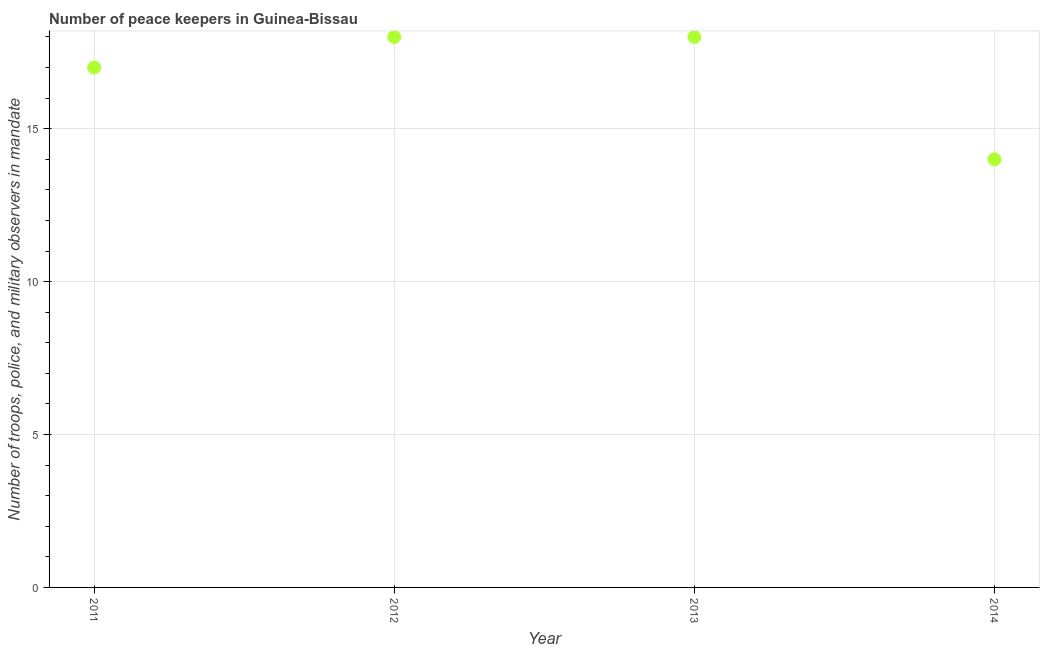What is the number of peace keepers in 2013?
Offer a terse response. 18. Across all years, what is the maximum number of peace keepers?
Ensure brevity in your answer.  18. Across all years, what is the minimum number of peace keepers?
Provide a succinct answer. 14. What is the sum of the number of peace keepers?
Give a very brief answer. 67. What is the difference between the number of peace keepers in 2012 and 2014?
Make the answer very short. 4. What is the average number of peace keepers per year?
Provide a short and direct response. 16.75. What is the ratio of the number of peace keepers in 2011 to that in 2014?
Offer a terse response. 1.21. Is the number of peace keepers in 2011 less than that in 2012?
Your response must be concise. Yes. What is the difference between the highest and the second highest number of peace keepers?
Your response must be concise. 0. Is the sum of the number of peace keepers in 2012 and 2013 greater than the maximum number of peace keepers across all years?
Make the answer very short. Yes. What is the difference between the highest and the lowest number of peace keepers?
Offer a very short reply. 4. In how many years, is the number of peace keepers greater than the average number of peace keepers taken over all years?
Offer a very short reply. 3. How many dotlines are there?
Offer a terse response. 1. Are the values on the major ticks of Y-axis written in scientific E-notation?
Give a very brief answer. No. Does the graph contain any zero values?
Provide a short and direct response. No. What is the title of the graph?
Your answer should be very brief. Number of peace keepers in Guinea-Bissau. What is the label or title of the Y-axis?
Your response must be concise. Number of troops, police, and military observers in mandate. What is the Number of troops, police, and military observers in mandate in 2012?
Ensure brevity in your answer.  18. What is the Number of troops, police, and military observers in mandate in 2014?
Ensure brevity in your answer.  14. What is the difference between the Number of troops, police, and military observers in mandate in 2011 and 2013?
Make the answer very short. -1. What is the difference between the Number of troops, police, and military observers in mandate in 2011 and 2014?
Keep it short and to the point. 3. What is the difference between the Number of troops, police, and military observers in mandate in 2012 and 2013?
Offer a very short reply. 0. What is the difference between the Number of troops, police, and military observers in mandate in 2012 and 2014?
Keep it short and to the point. 4. What is the difference between the Number of troops, police, and military observers in mandate in 2013 and 2014?
Offer a terse response. 4. What is the ratio of the Number of troops, police, and military observers in mandate in 2011 to that in 2012?
Your response must be concise. 0.94. What is the ratio of the Number of troops, police, and military observers in mandate in 2011 to that in 2013?
Provide a succinct answer. 0.94. What is the ratio of the Number of troops, police, and military observers in mandate in 2011 to that in 2014?
Provide a succinct answer. 1.21. What is the ratio of the Number of troops, police, and military observers in mandate in 2012 to that in 2013?
Keep it short and to the point. 1. What is the ratio of the Number of troops, police, and military observers in mandate in 2012 to that in 2014?
Offer a terse response. 1.29. What is the ratio of the Number of troops, police, and military observers in mandate in 2013 to that in 2014?
Offer a very short reply. 1.29. 